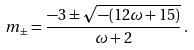Convert formula to latex. <formula><loc_0><loc_0><loc_500><loc_500>m _ { \pm } = \frac { - 3 \pm \sqrt { - ( 1 2 \omega + 1 5 ) } } { \omega + 2 } \, .</formula> 